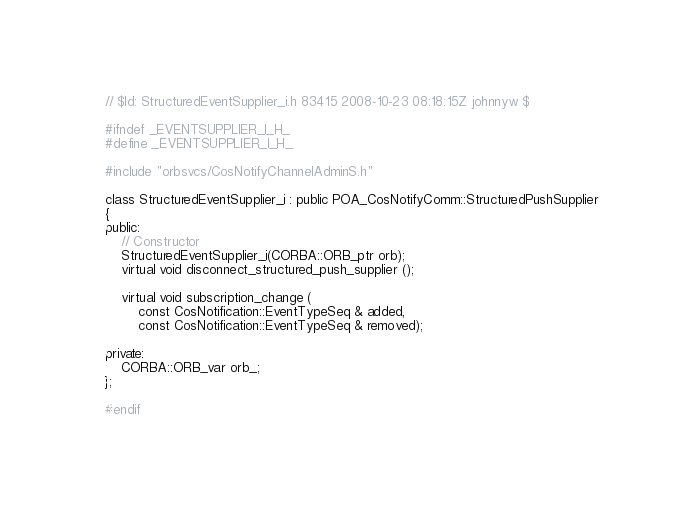Convert code to text. <code><loc_0><loc_0><loc_500><loc_500><_C_>// $Id: StructuredEventSupplier_i.h 83415 2008-10-23 08:18:15Z johnnyw $

#ifndef _EVENTSUPPLIER_I_H_
#define _EVENTSUPPLIER_I_H_

#include "orbsvcs/CosNotifyChannelAdminS.h"

class StructuredEventSupplier_i : public POA_CosNotifyComm::StructuredPushSupplier
{
public:
    // Constructor
    StructuredEventSupplier_i(CORBA::ORB_ptr orb);
    virtual void disconnect_structured_push_supplier ();

    virtual void subscription_change (
        const CosNotification::EventTypeSeq & added,
        const CosNotification::EventTypeSeq & removed);

private:
    CORBA::ORB_var orb_;
};

#endif
</code> 